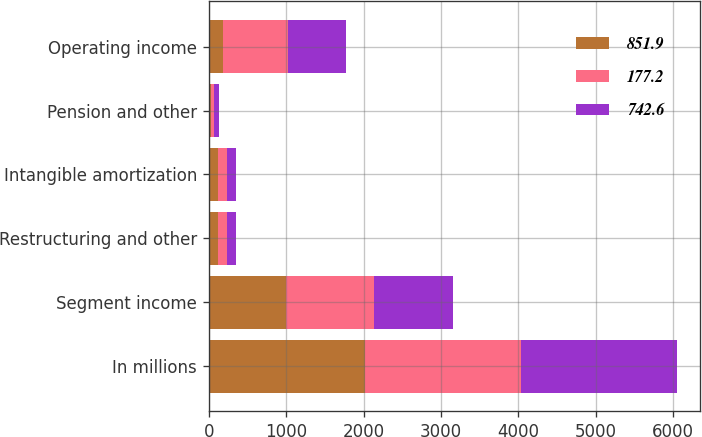Convert chart to OTSL. <chart><loc_0><loc_0><loc_500><loc_500><stacked_bar_chart><ecel><fcel>In millions<fcel>Segment income<fcel>Restructuring and other<fcel>Intangible amortization<fcel>Pension and other<fcel>Operating income<nl><fcel>851.9<fcel>2015<fcel>1001.2<fcel>120.9<fcel>121.4<fcel>23<fcel>177.2<nl><fcel>177.2<fcel>2014<fcel>1135.7<fcel>109.6<fcel>114<fcel>49.9<fcel>851.9<nl><fcel>742.6<fcel>2013<fcel>1013.2<fcel>119.9<fcel>110.9<fcel>63.2<fcel>742.6<nl></chart> 